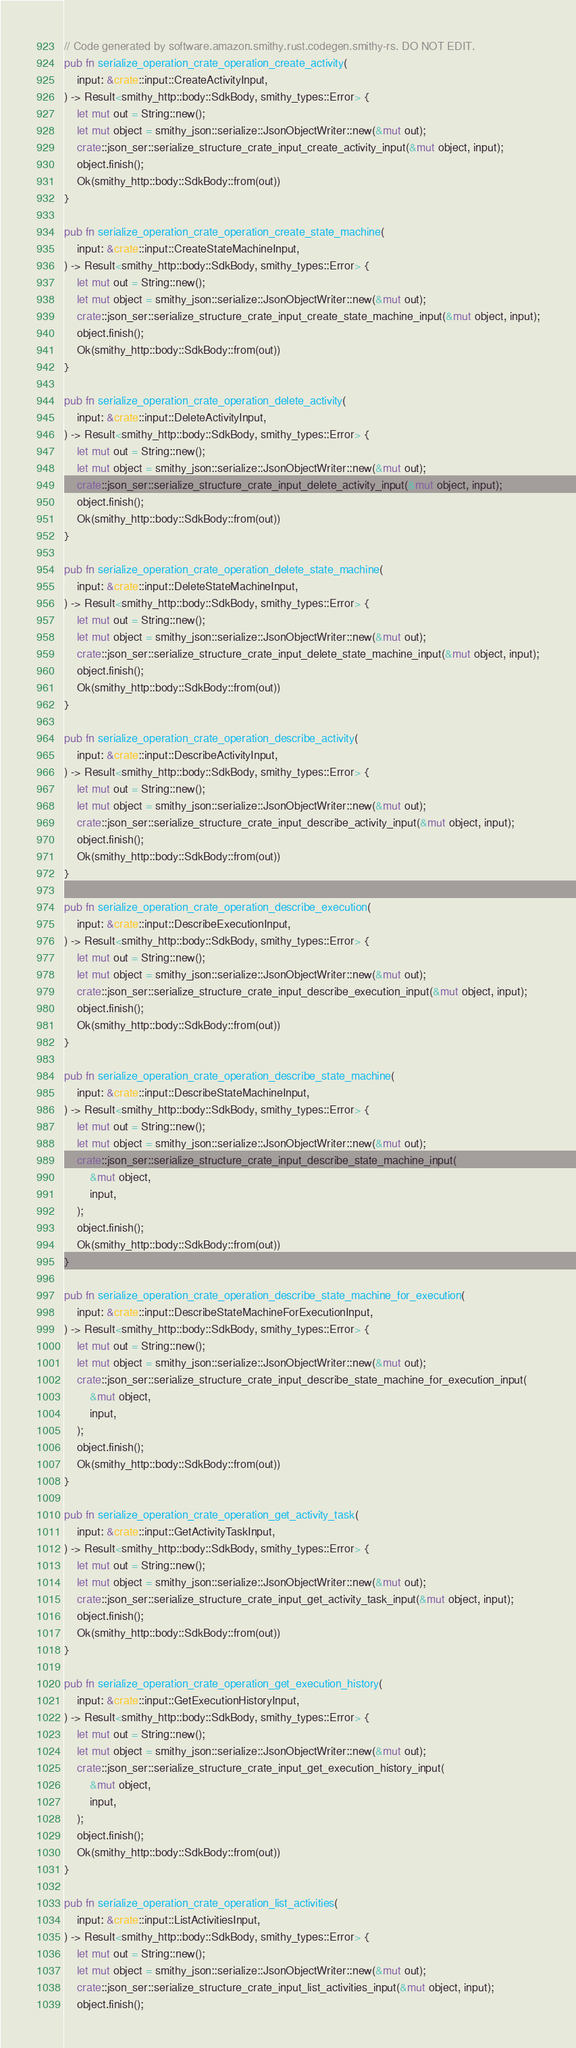Convert code to text. <code><loc_0><loc_0><loc_500><loc_500><_Rust_>// Code generated by software.amazon.smithy.rust.codegen.smithy-rs. DO NOT EDIT.
pub fn serialize_operation_crate_operation_create_activity(
    input: &crate::input::CreateActivityInput,
) -> Result<smithy_http::body::SdkBody, smithy_types::Error> {
    let mut out = String::new();
    let mut object = smithy_json::serialize::JsonObjectWriter::new(&mut out);
    crate::json_ser::serialize_structure_crate_input_create_activity_input(&mut object, input);
    object.finish();
    Ok(smithy_http::body::SdkBody::from(out))
}

pub fn serialize_operation_crate_operation_create_state_machine(
    input: &crate::input::CreateStateMachineInput,
) -> Result<smithy_http::body::SdkBody, smithy_types::Error> {
    let mut out = String::new();
    let mut object = smithy_json::serialize::JsonObjectWriter::new(&mut out);
    crate::json_ser::serialize_structure_crate_input_create_state_machine_input(&mut object, input);
    object.finish();
    Ok(smithy_http::body::SdkBody::from(out))
}

pub fn serialize_operation_crate_operation_delete_activity(
    input: &crate::input::DeleteActivityInput,
) -> Result<smithy_http::body::SdkBody, smithy_types::Error> {
    let mut out = String::new();
    let mut object = smithy_json::serialize::JsonObjectWriter::new(&mut out);
    crate::json_ser::serialize_structure_crate_input_delete_activity_input(&mut object, input);
    object.finish();
    Ok(smithy_http::body::SdkBody::from(out))
}

pub fn serialize_operation_crate_operation_delete_state_machine(
    input: &crate::input::DeleteStateMachineInput,
) -> Result<smithy_http::body::SdkBody, smithy_types::Error> {
    let mut out = String::new();
    let mut object = smithy_json::serialize::JsonObjectWriter::new(&mut out);
    crate::json_ser::serialize_structure_crate_input_delete_state_machine_input(&mut object, input);
    object.finish();
    Ok(smithy_http::body::SdkBody::from(out))
}

pub fn serialize_operation_crate_operation_describe_activity(
    input: &crate::input::DescribeActivityInput,
) -> Result<smithy_http::body::SdkBody, smithy_types::Error> {
    let mut out = String::new();
    let mut object = smithy_json::serialize::JsonObjectWriter::new(&mut out);
    crate::json_ser::serialize_structure_crate_input_describe_activity_input(&mut object, input);
    object.finish();
    Ok(smithy_http::body::SdkBody::from(out))
}

pub fn serialize_operation_crate_operation_describe_execution(
    input: &crate::input::DescribeExecutionInput,
) -> Result<smithy_http::body::SdkBody, smithy_types::Error> {
    let mut out = String::new();
    let mut object = smithy_json::serialize::JsonObjectWriter::new(&mut out);
    crate::json_ser::serialize_structure_crate_input_describe_execution_input(&mut object, input);
    object.finish();
    Ok(smithy_http::body::SdkBody::from(out))
}

pub fn serialize_operation_crate_operation_describe_state_machine(
    input: &crate::input::DescribeStateMachineInput,
) -> Result<smithy_http::body::SdkBody, smithy_types::Error> {
    let mut out = String::new();
    let mut object = smithy_json::serialize::JsonObjectWriter::new(&mut out);
    crate::json_ser::serialize_structure_crate_input_describe_state_machine_input(
        &mut object,
        input,
    );
    object.finish();
    Ok(smithy_http::body::SdkBody::from(out))
}

pub fn serialize_operation_crate_operation_describe_state_machine_for_execution(
    input: &crate::input::DescribeStateMachineForExecutionInput,
) -> Result<smithy_http::body::SdkBody, smithy_types::Error> {
    let mut out = String::new();
    let mut object = smithy_json::serialize::JsonObjectWriter::new(&mut out);
    crate::json_ser::serialize_structure_crate_input_describe_state_machine_for_execution_input(
        &mut object,
        input,
    );
    object.finish();
    Ok(smithy_http::body::SdkBody::from(out))
}

pub fn serialize_operation_crate_operation_get_activity_task(
    input: &crate::input::GetActivityTaskInput,
) -> Result<smithy_http::body::SdkBody, smithy_types::Error> {
    let mut out = String::new();
    let mut object = smithy_json::serialize::JsonObjectWriter::new(&mut out);
    crate::json_ser::serialize_structure_crate_input_get_activity_task_input(&mut object, input);
    object.finish();
    Ok(smithy_http::body::SdkBody::from(out))
}

pub fn serialize_operation_crate_operation_get_execution_history(
    input: &crate::input::GetExecutionHistoryInput,
) -> Result<smithy_http::body::SdkBody, smithy_types::Error> {
    let mut out = String::new();
    let mut object = smithy_json::serialize::JsonObjectWriter::new(&mut out);
    crate::json_ser::serialize_structure_crate_input_get_execution_history_input(
        &mut object,
        input,
    );
    object.finish();
    Ok(smithy_http::body::SdkBody::from(out))
}

pub fn serialize_operation_crate_operation_list_activities(
    input: &crate::input::ListActivitiesInput,
) -> Result<smithy_http::body::SdkBody, smithy_types::Error> {
    let mut out = String::new();
    let mut object = smithy_json::serialize::JsonObjectWriter::new(&mut out);
    crate::json_ser::serialize_structure_crate_input_list_activities_input(&mut object, input);
    object.finish();</code> 